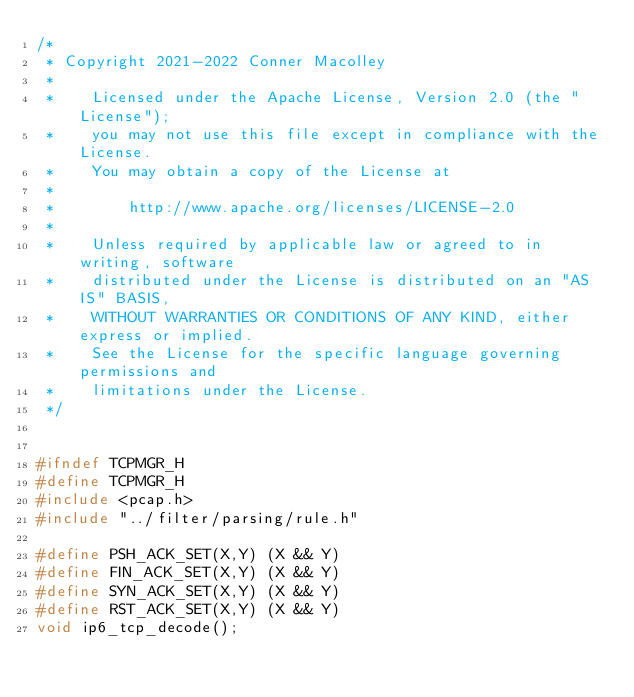<code> <loc_0><loc_0><loc_500><loc_500><_C_>/*
 * Copyright 2021-2022 Conner Macolley
 *
 *    Licensed under the Apache License, Version 2.0 (the "License");
 *    you may not use this file except in compliance with the License.
 *    You may obtain a copy of the License at
 *
 *        http://www.apache.org/licenses/LICENSE-2.0
 *
 *    Unless required by applicable law or agreed to in writing, software
 *    distributed under the License is distributed on an "AS IS" BASIS,
 *    WITHOUT WARRANTIES OR CONDITIONS OF ANY KIND, either express or implied.
 *    See the License for the specific language governing permissions and
 *    limitations under the License.
 */


#ifndef TCPMGR_H
#define TCPMGR_H
#include <pcap.h>
#include "../filter/parsing/rule.h"

#define PSH_ACK_SET(X,Y) (X && Y)
#define FIN_ACK_SET(X,Y) (X && Y)
#define SYN_ACK_SET(X,Y) (X && Y)
#define RST_ACK_SET(X,Y) (X && Y)
void ip6_tcp_decode();
</code> 